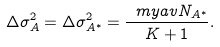Convert formula to latex. <formula><loc_0><loc_0><loc_500><loc_500>\Delta \sigma ^ { 2 } _ { A } = \Delta \sigma ^ { 2 } _ { A ^ { * } } = \frac { \ m y a v { N _ { A ^ { * } } } } { K + 1 } .</formula> 